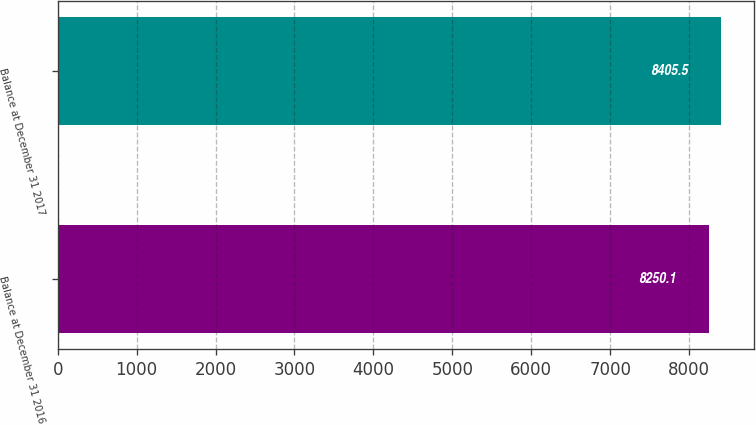<chart> <loc_0><loc_0><loc_500><loc_500><bar_chart><fcel>Balance at December 31 2016<fcel>Balance at December 31 2017<nl><fcel>8250.1<fcel>8405.5<nl></chart> 